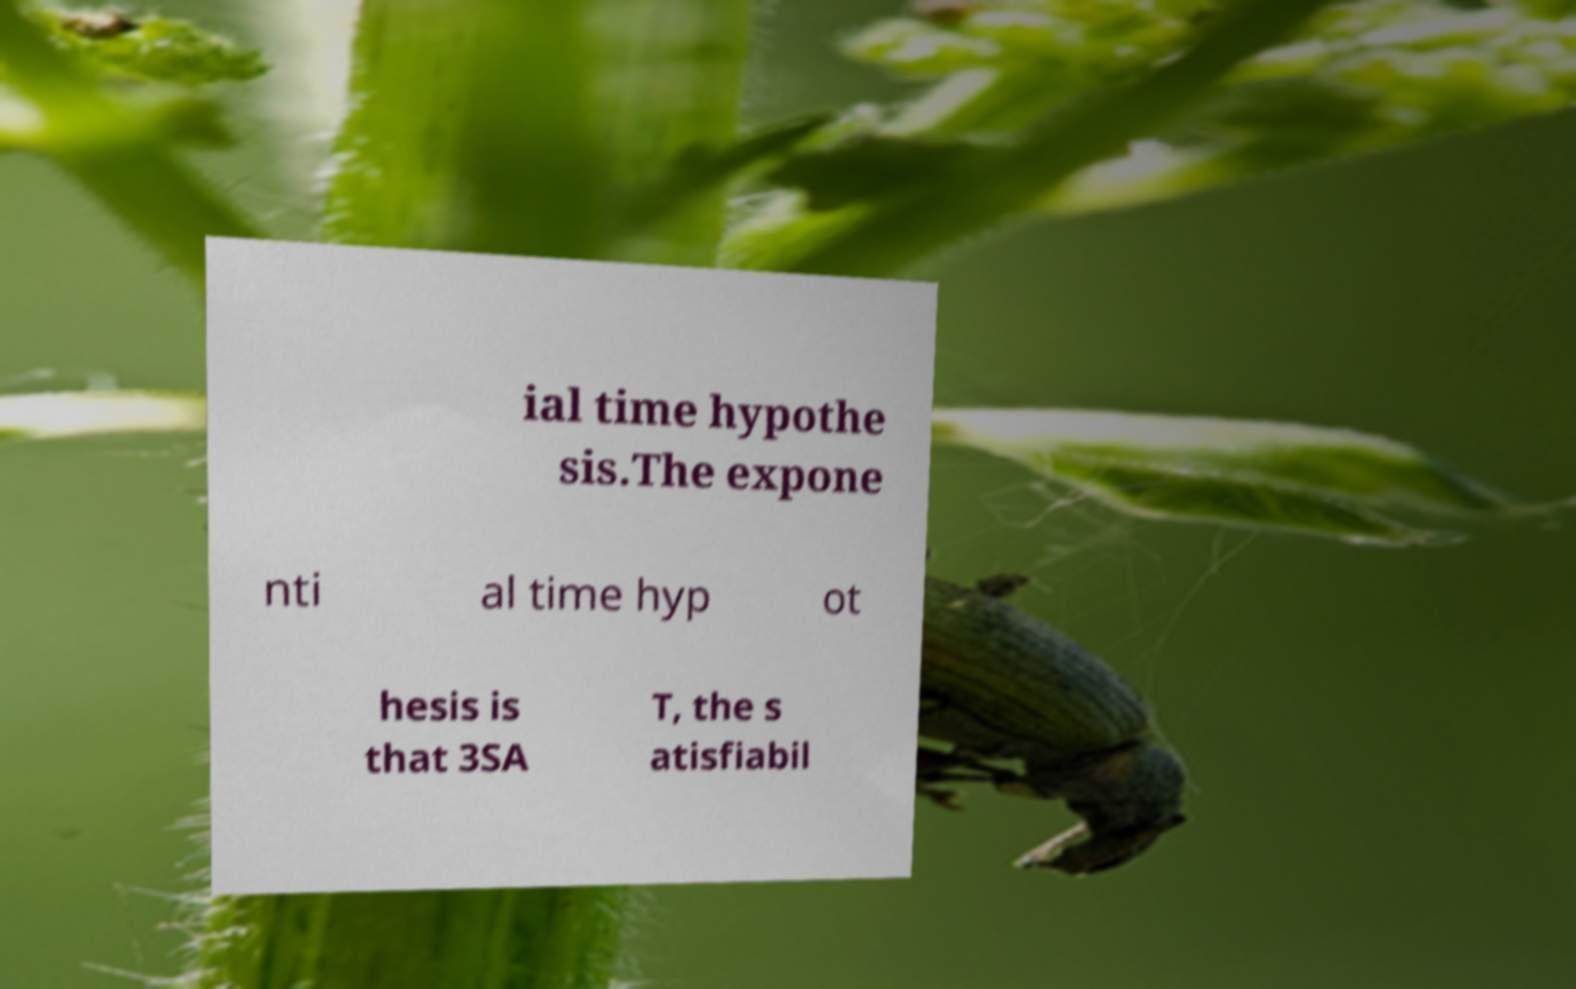Could you assist in decoding the text presented in this image and type it out clearly? ial time hypothe sis.The expone nti al time hyp ot hesis is that 3SA T, the s atisfiabil 